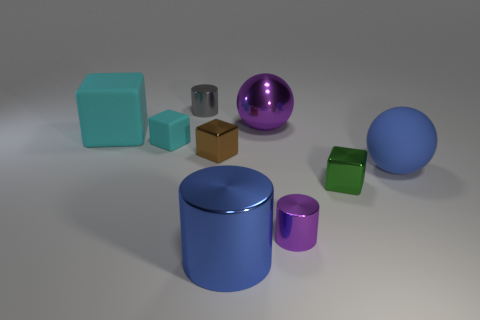Are there more brown objects than red matte things?
Ensure brevity in your answer.  Yes. How many things are objects behind the big blue shiny thing or small brown shiny spheres?
Offer a terse response. 8. There is a cyan cube that is to the right of the big cube; how many cylinders are in front of it?
Your response must be concise. 2. What is the size of the cyan block to the right of the large object that is on the left side of the tiny cylinder that is behind the tiny cyan cube?
Offer a terse response. Small. There is a tiny cylinder to the right of the tiny brown object; does it have the same color as the large metallic cylinder?
Your answer should be very brief. No. What is the size of the brown thing that is the same shape as the green thing?
Give a very brief answer. Small. What number of things are either metallic cylinders in front of the purple metal ball or large matte things in front of the big matte cube?
Offer a terse response. 3. What shape is the cyan thing that is left of the cyan thing in front of the large cyan object?
Your response must be concise. Cube. Are there any other things that are the same color as the large cylinder?
Your response must be concise. Yes. Is there anything else that is the same size as the blue shiny cylinder?
Provide a succinct answer. Yes. 